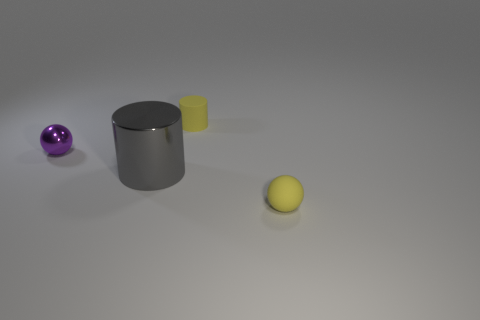Add 2 big purple matte objects. How many objects exist? 6 Add 3 tiny yellow matte balls. How many tiny yellow matte balls exist? 4 Subtract 0 gray spheres. How many objects are left? 4 Subtract all tiny purple rubber balls. Subtract all tiny yellow rubber spheres. How many objects are left? 3 Add 2 yellow rubber balls. How many yellow rubber balls are left? 3 